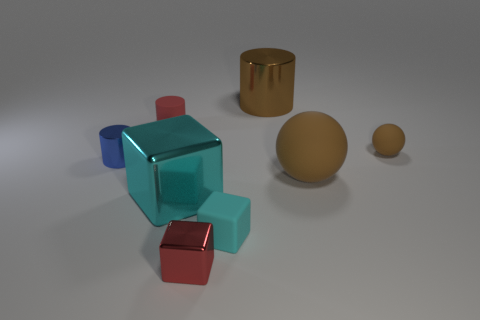Are there any other things that have the same size as the blue thing?
Your answer should be compact. Yes. What is the size of the object that is in front of the blue metallic thing and behind the large cyan block?
Ensure brevity in your answer.  Large. What is the shape of the big brown thing that is the same material as the blue thing?
Make the answer very short. Cylinder. Do the tiny cyan object and the large brown thing in front of the large brown metal thing have the same material?
Your response must be concise. Yes. Are there any large brown things in front of the tiny ball to the right of the cyan matte thing?
Give a very brief answer. Yes. What material is the other brown object that is the same shape as the large rubber thing?
Ensure brevity in your answer.  Rubber. There is a brown matte ball that is behind the tiny blue object; how many brown spheres are in front of it?
Make the answer very short. 1. Are there any other things that have the same color as the rubber cube?
Make the answer very short. Yes. How many objects are either small cyan metallic blocks or cylinders that are behind the small red cylinder?
Offer a very short reply. 1. The brown sphere that is behind the large brown object that is in front of the large object behind the tiny matte cylinder is made of what material?
Keep it short and to the point. Rubber. 